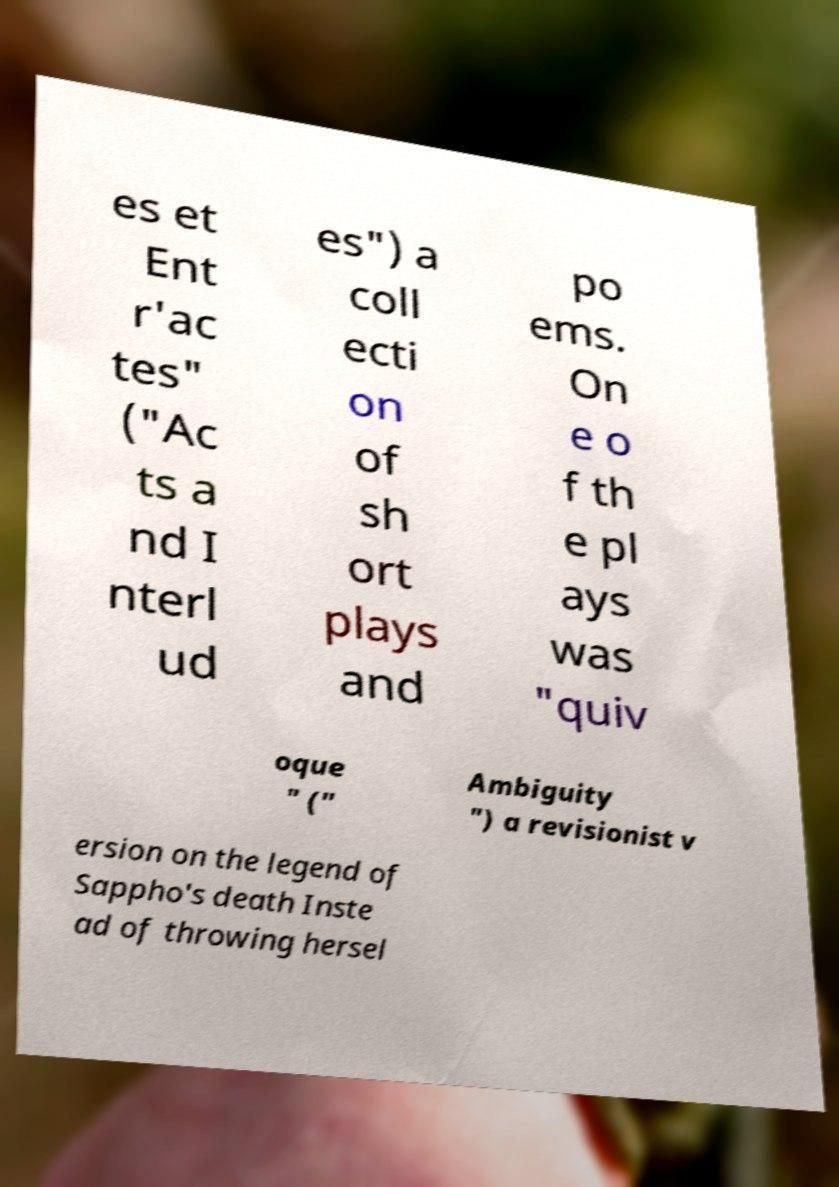I need the written content from this picture converted into text. Can you do that? es et Ent r'ac tes" ("Ac ts a nd I nterl ud es") a coll ecti on of sh ort plays and po ems. On e o f th e pl ays was "quiv oque " (" Ambiguity ") a revisionist v ersion on the legend of Sappho's death Inste ad of throwing hersel 